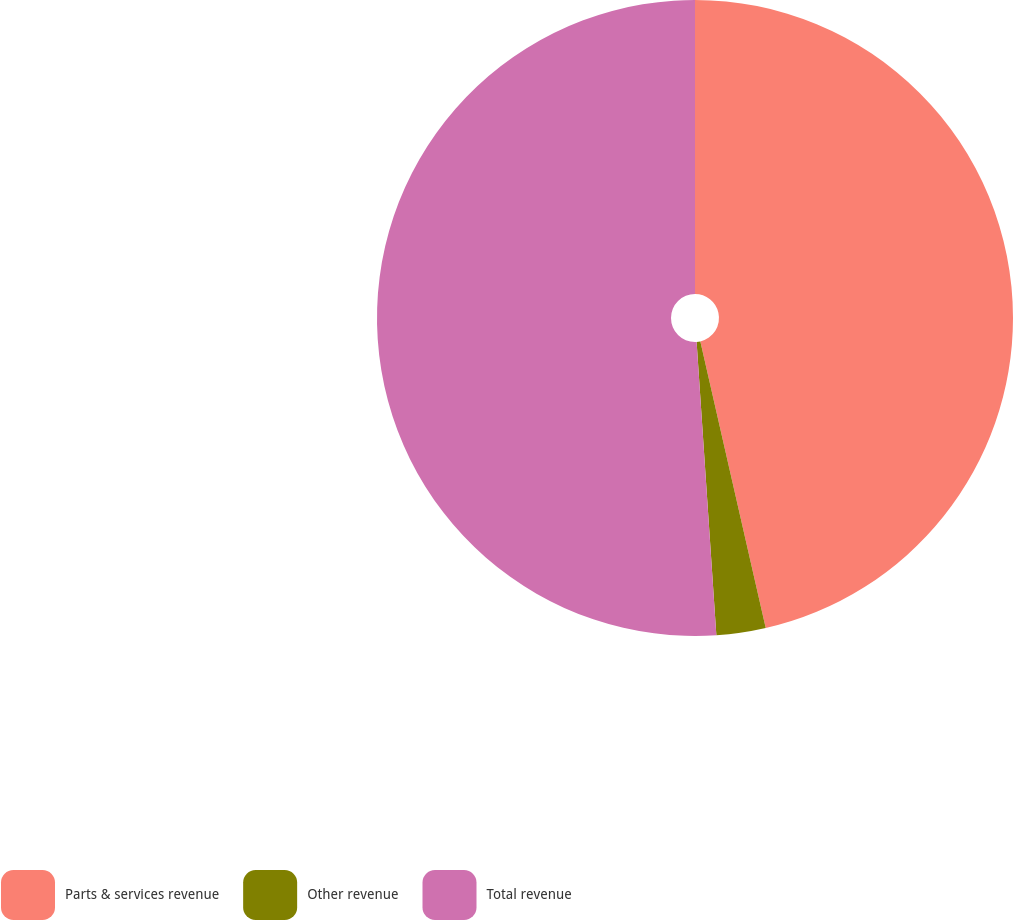Convert chart. <chart><loc_0><loc_0><loc_500><loc_500><pie_chart><fcel>Parts & services revenue<fcel>Other revenue<fcel>Total revenue<nl><fcel>46.43%<fcel>2.5%<fcel>51.07%<nl></chart> 